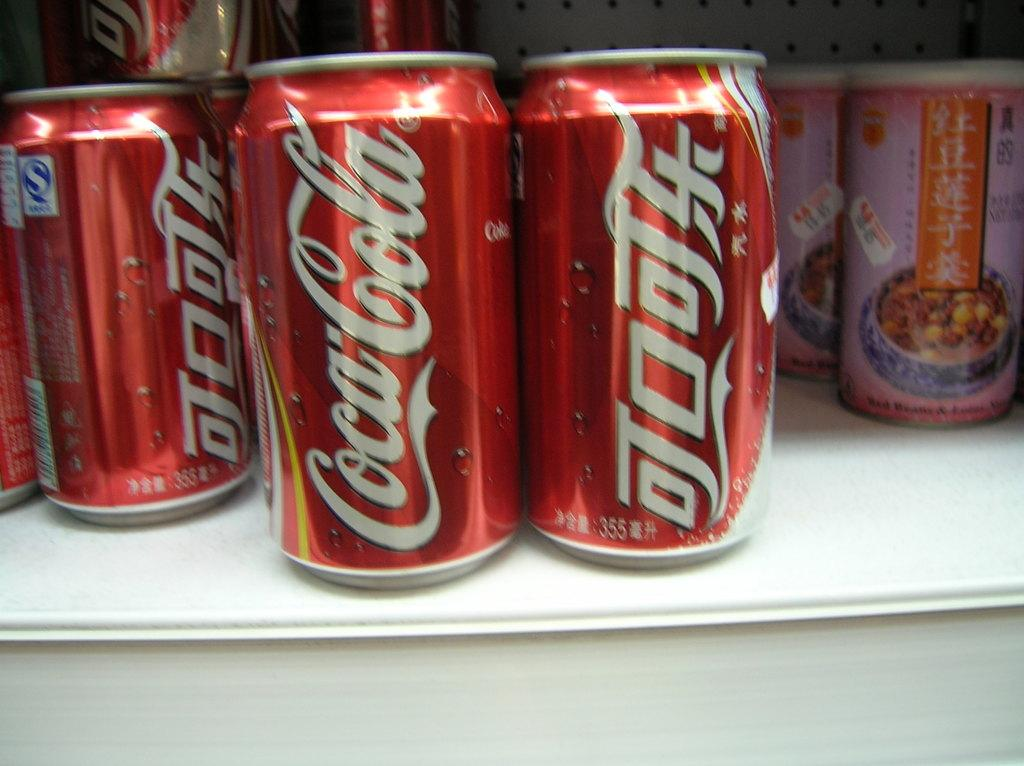<image>
Share a concise interpretation of the image provided. Cans of coca cola on a shelf next to chinese food 